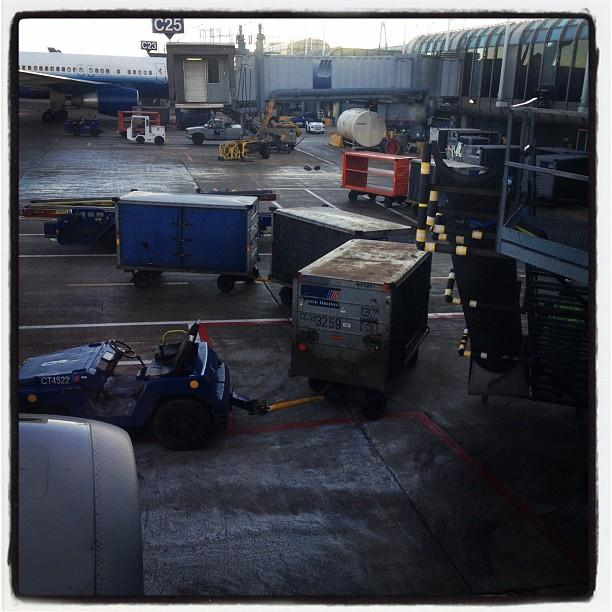What is the blue vehicle doing? Please explain your reasoning. pulling. It has luggage carts hooked to the back 